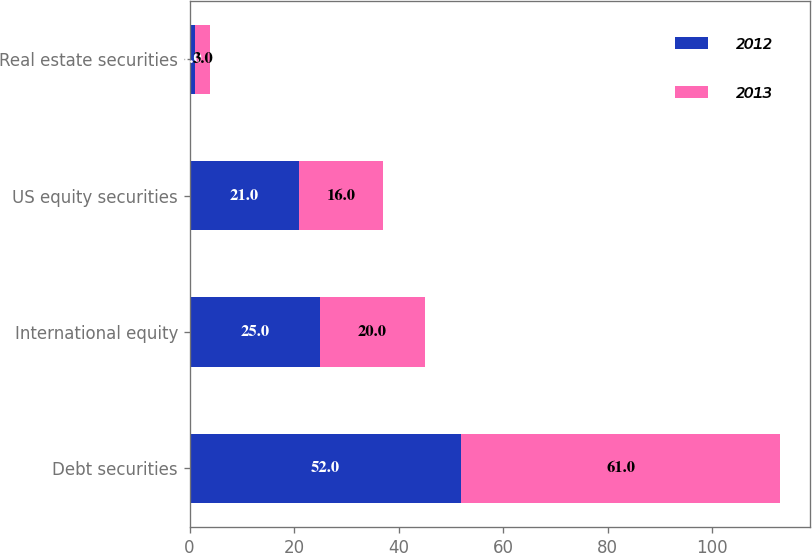Convert chart to OTSL. <chart><loc_0><loc_0><loc_500><loc_500><stacked_bar_chart><ecel><fcel>Debt securities<fcel>International equity<fcel>US equity securities<fcel>Real estate securities<nl><fcel>2012<fcel>52<fcel>25<fcel>21<fcel>1<nl><fcel>2013<fcel>61<fcel>20<fcel>16<fcel>3<nl></chart> 